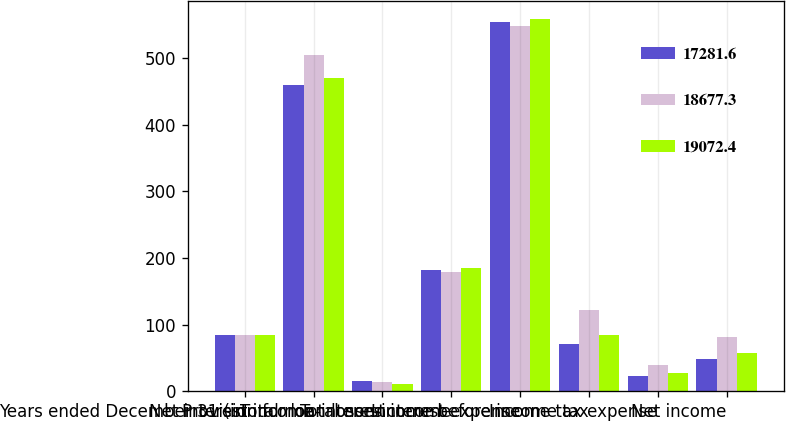<chart> <loc_0><loc_0><loc_500><loc_500><stacked_bar_chart><ecel><fcel>Years ended December 31 (in<fcel>Net interest income<fcel>Provision for loan losses<fcel>Total non-interest income<fcel>Total non-interest expense<fcel>Income before income tax<fcel>Income tax expense<fcel>Net income<nl><fcel>17281.6<fcel>85.1<fcel>459.6<fcel>15.4<fcel>181.6<fcel>554.8<fcel>71<fcel>22.5<fcel>48.5<nl><fcel>18677.3<fcel>85.1<fcel>504<fcel>14<fcel>179.5<fcel>548.3<fcel>121.2<fcel>39.4<fcel>81.8<nl><fcel>19072.4<fcel>85.1<fcel>469.7<fcel>10.9<fcel>184.4<fcel>558.1<fcel>85.1<fcel>27.8<fcel>57.3<nl></chart> 